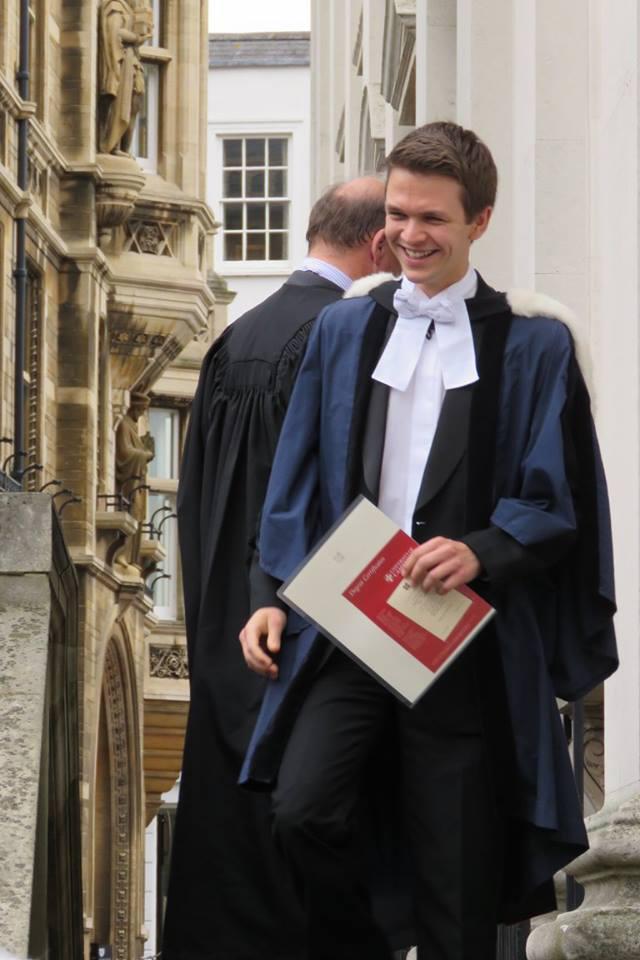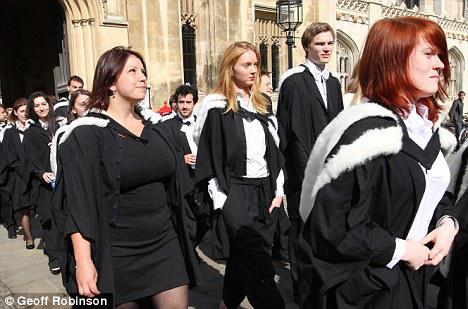The first image is the image on the left, the second image is the image on the right. For the images displayed, is the sentence "An image contains one front-facing graduate, a young man wearing a white bow around his neck and no cap." factually correct? Answer yes or no. Yes. The first image is the image on the left, the second image is the image on the right. Analyze the images presented: Is the assertion "The left image contains no more than two graduation students." valid? Answer yes or no. Yes. 